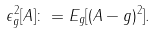<formula> <loc_0><loc_0><loc_500><loc_500>\epsilon ^ { 2 } _ { g } [ A ] \colon = E _ { g } [ ( A - g ) ^ { 2 } ] .</formula> 